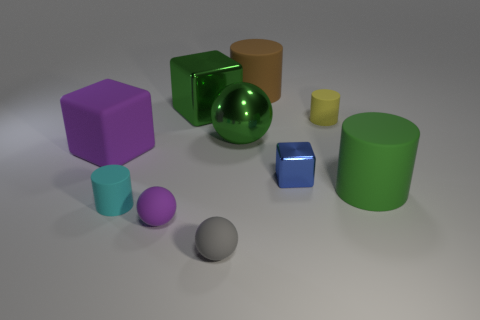Does the big shiny sphere have the same color as the big shiny block?
Provide a succinct answer. Yes. Are there any other things that have the same size as the gray rubber thing?
Give a very brief answer. Yes. How many large matte cylinders are both to the left of the small block and in front of the brown rubber object?
Offer a terse response. 0. How many purple rubber things are behind the small cyan cylinder?
Offer a very short reply. 1. Are there any brown metallic things that have the same shape as the large brown rubber thing?
Make the answer very short. No. There is a tiny gray object; is it the same shape as the purple object that is in front of the tiny blue cube?
Ensure brevity in your answer.  Yes. How many cylinders are either big green things or rubber objects?
Ensure brevity in your answer.  4. There is a tiny rubber object that is behind the large green cylinder; what is its shape?
Keep it short and to the point. Cylinder. How many other blocks are made of the same material as the tiny block?
Your answer should be very brief. 1. Are there fewer matte things on the right side of the tiny gray matte thing than gray spheres?
Offer a terse response. No. 